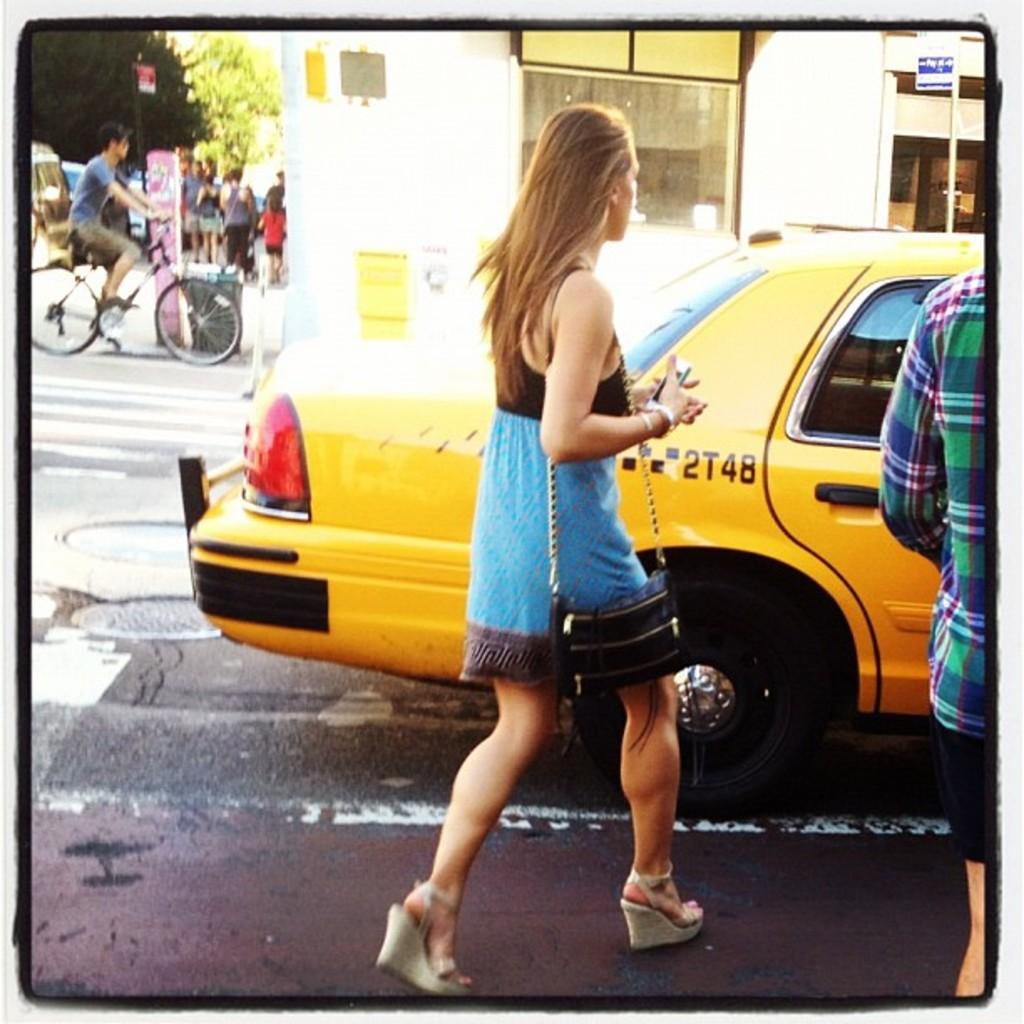<image>
Share a concise interpretation of the image provided. A woman walks over to a Taxi that is number 2T48. 